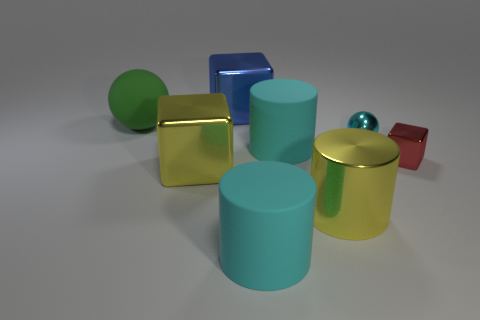Subtract 1 blocks. How many blocks are left? 2 Add 2 cyan cylinders. How many objects exist? 10 Subtract all spheres. How many objects are left? 6 Add 3 big yellow metal things. How many big yellow metal things exist? 5 Subtract 0 yellow balls. How many objects are left? 8 Subtract all blue cubes. Subtract all big blue shiny blocks. How many objects are left? 6 Add 5 blocks. How many blocks are left? 8 